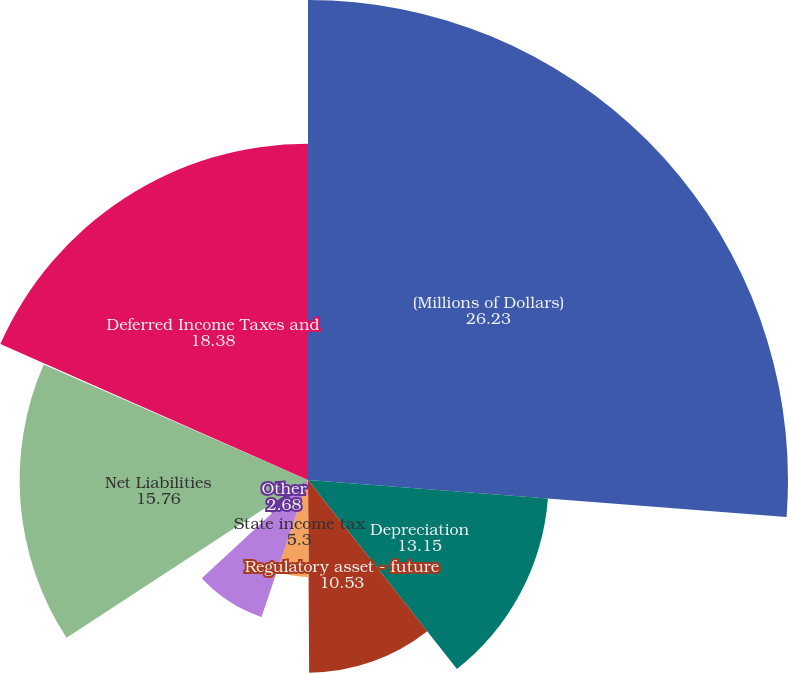Convert chart to OTSL. <chart><loc_0><loc_0><loc_500><loc_500><pie_chart><fcel>(Millions of Dollars)<fcel>Depreciation<fcel>Regulatory asset - future<fcel>State income tax<fcel>Capitalized overheads<fcel>Other<fcel>Net Liabilities<fcel>Investment Tax Credits<fcel>Deferred Income Taxes and<nl><fcel>26.23%<fcel>13.15%<fcel>10.53%<fcel>5.3%<fcel>7.91%<fcel>2.68%<fcel>15.76%<fcel>0.07%<fcel>18.38%<nl></chart> 